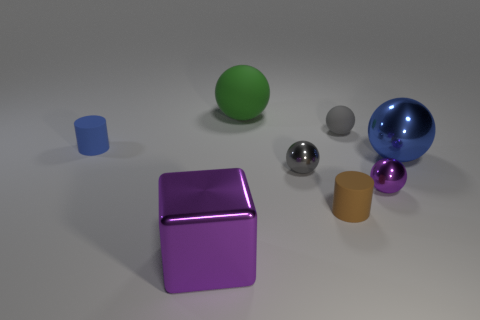Subtract all green matte spheres. How many spheres are left? 4 Subtract all yellow spheres. Subtract all blue blocks. How many spheres are left? 5 Add 1 tiny metal blocks. How many objects exist? 9 Subtract all cylinders. How many objects are left? 6 Add 7 big green matte balls. How many big green matte balls are left? 8 Add 2 brown objects. How many brown objects exist? 3 Subtract 0 red balls. How many objects are left? 8 Subtract all yellow shiny balls. Subtract all tiny gray rubber spheres. How many objects are left? 7 